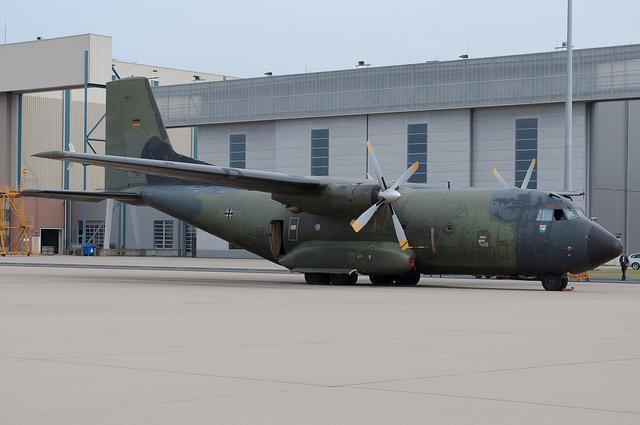How many engines does the plane have?
Give a very brief answer. 2. 